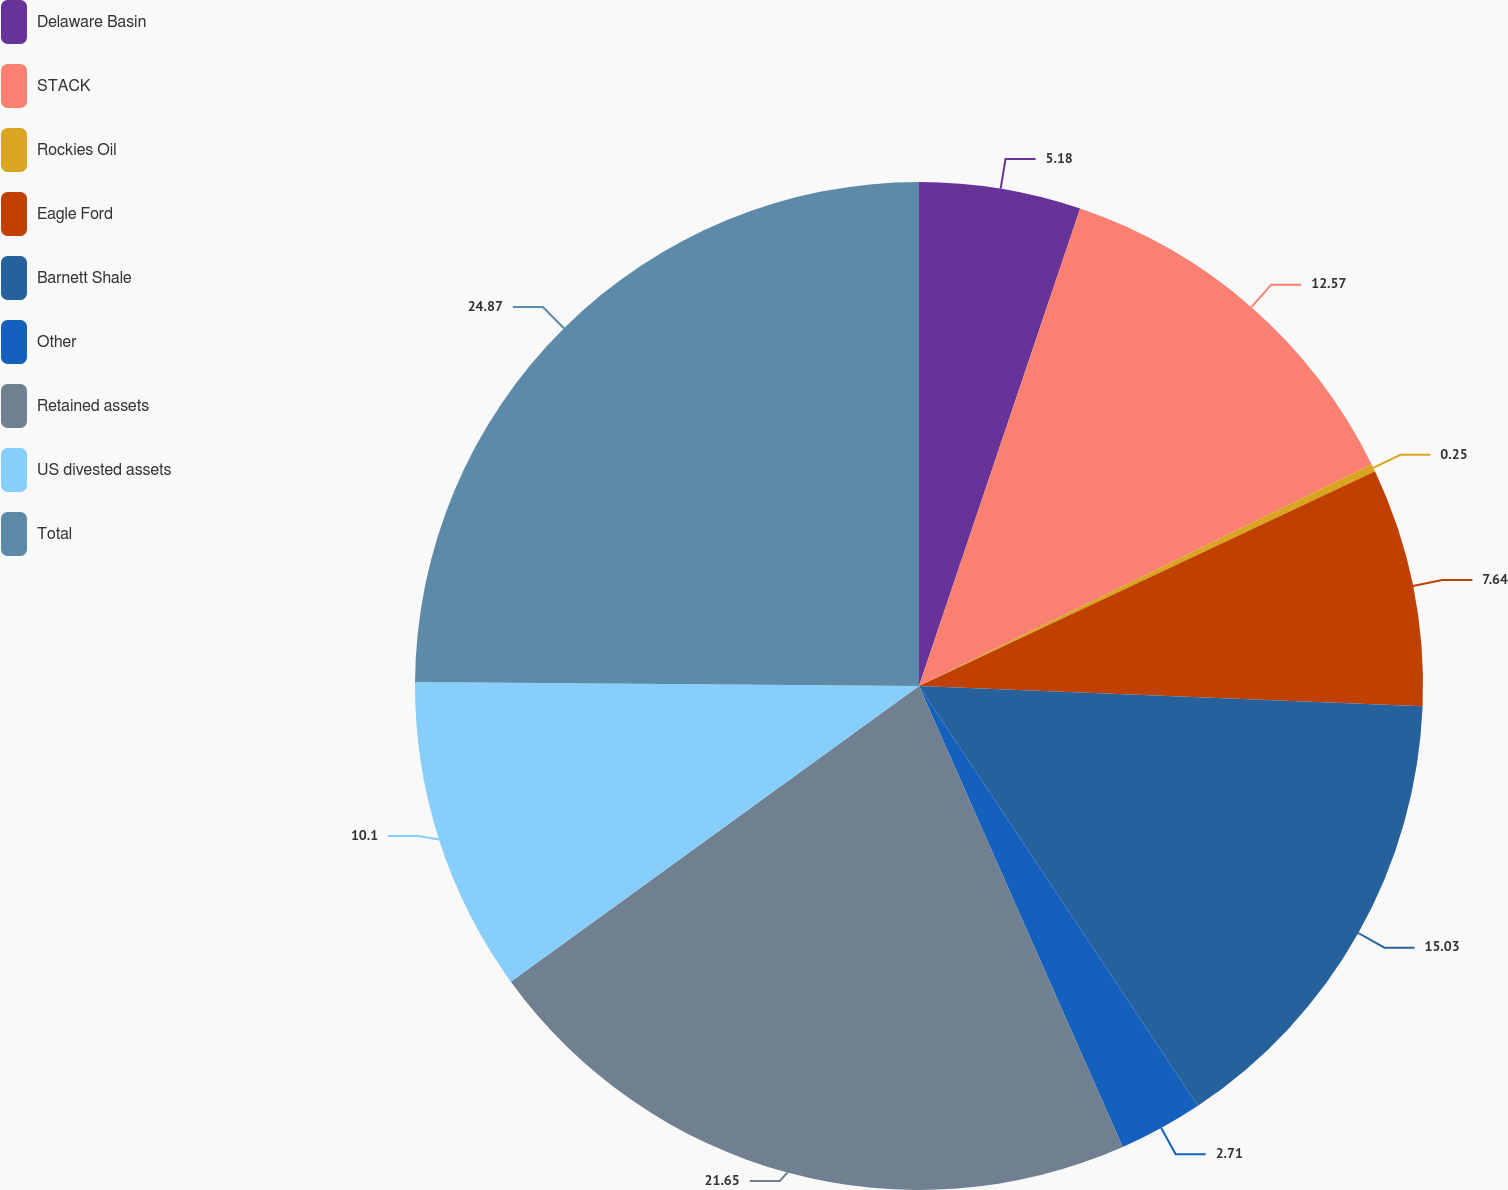Convert chart. <chart><loc_0><loc_0><loc_500><loc_500><pie_chart><fcel>Delaware Basin<fcel>STACK<fcel>Rockies Oil<fcel>Eagle Ford<fcel>Barnett Shale<fcel>Other<fcel>Retained assets<fcel>US divested assets<fcel>Total<nl><fcel>5.18%<fcel>12.57%<fcel>0.25%<fcel>7.64%<fcel>15.03%<fcel>2.71%<fcel>21.65%<fcel>10.1%<fcel>24.88%<nl></chart> 